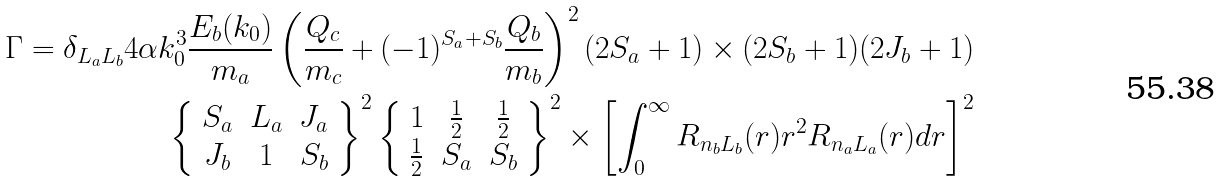<formula> <loc_0><loc_0><loc_500><loc_500>\Gamma = \delta _ { L _ { a } L _ { b } } 4 \alpha k ^ { 3 } _ { 0 } \frac { E _ { b } ( k _ { 0 } ) } { m _ { a } } \left ( \frac { Q _ { c } } { m _ { c } } + ( - 1 ) ^ { S _ { a } + S _ { b } } \frac { Q _ { b } } { m _ { b } } \right ) ^ { 2 } ( 2 S _ { a } + 1 ) \times ( 2 S _ { b } + 1 ) ( 2 J _ { b } + 1 ) \\ \left \{ \begin{array} { c c c } S _ { a } & L _ { a } & J _ { a } \\ J _ { b } & 1 & S _ { b } \end{array} \right \} ^ { 2 } \left \{ \begin{array} { c c c } 1 & \frac { 1 } { 2 } & \frac { 1 } { 2 } \\ \frac { 1 } { 2 } & S _ { a } & S _ { b } \end{array} \right \} ^ { 2 } \times \left [ \int ^ { \infty } _ { 0 } R _ { n _ { b } L _ { b } } ( r ) r ^ { 2 } R _ { n _ { a } L _ { a } } ( r ) d r \right ] ^ { 2 }</formula> 